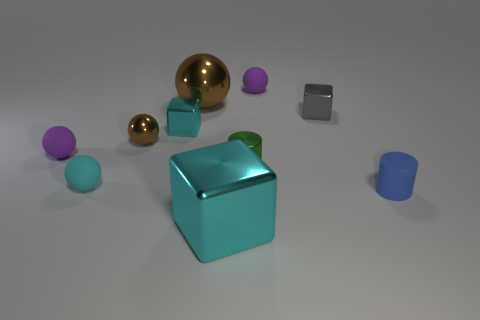Subtract all tiny metallic cubes. How many cubes are left? 1 Subtract all yellow cubes. How many brown spheres are left? 2 Subtract all purple spheres. How many spheres are left? 3 Subtract all purple spheres. Subtract all green cylinders. How many spheres are left? 3 Subtract all spheres. Subtract all tiny brown metallic things. How many objects are left? 4 Add 3 tiny shiny blocks. How many tiny shiny blocks are left? 5 Add 5 big cyan blocks. How many big cyan blocks exist? 6 Subtract 0 blue blocks. How many objects are left? 10 Subtract all blocks. How many objects are left? 7 